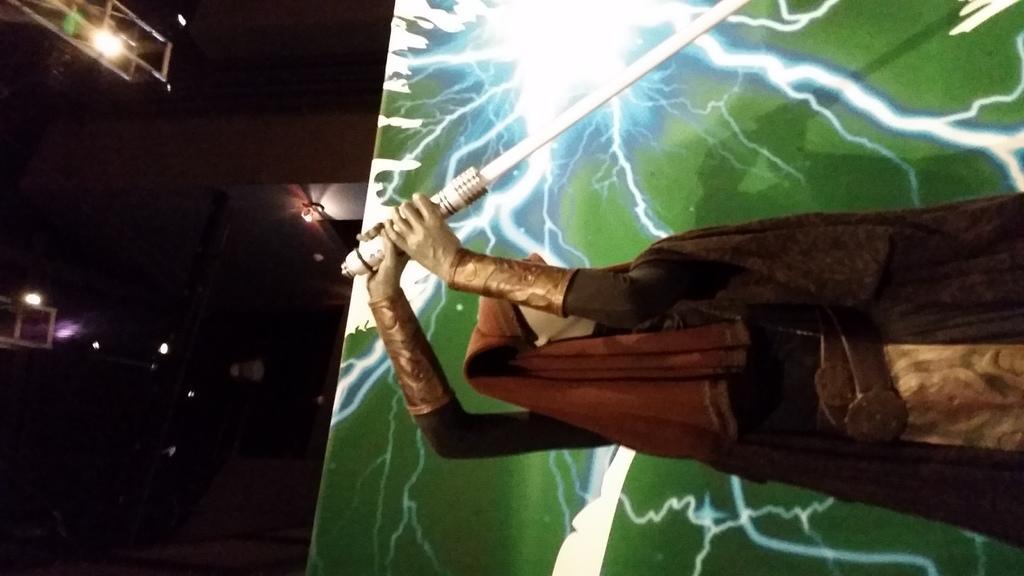In one or two sentences, can you explain what this image depicts? In this image we can see a statue holding a sword. 